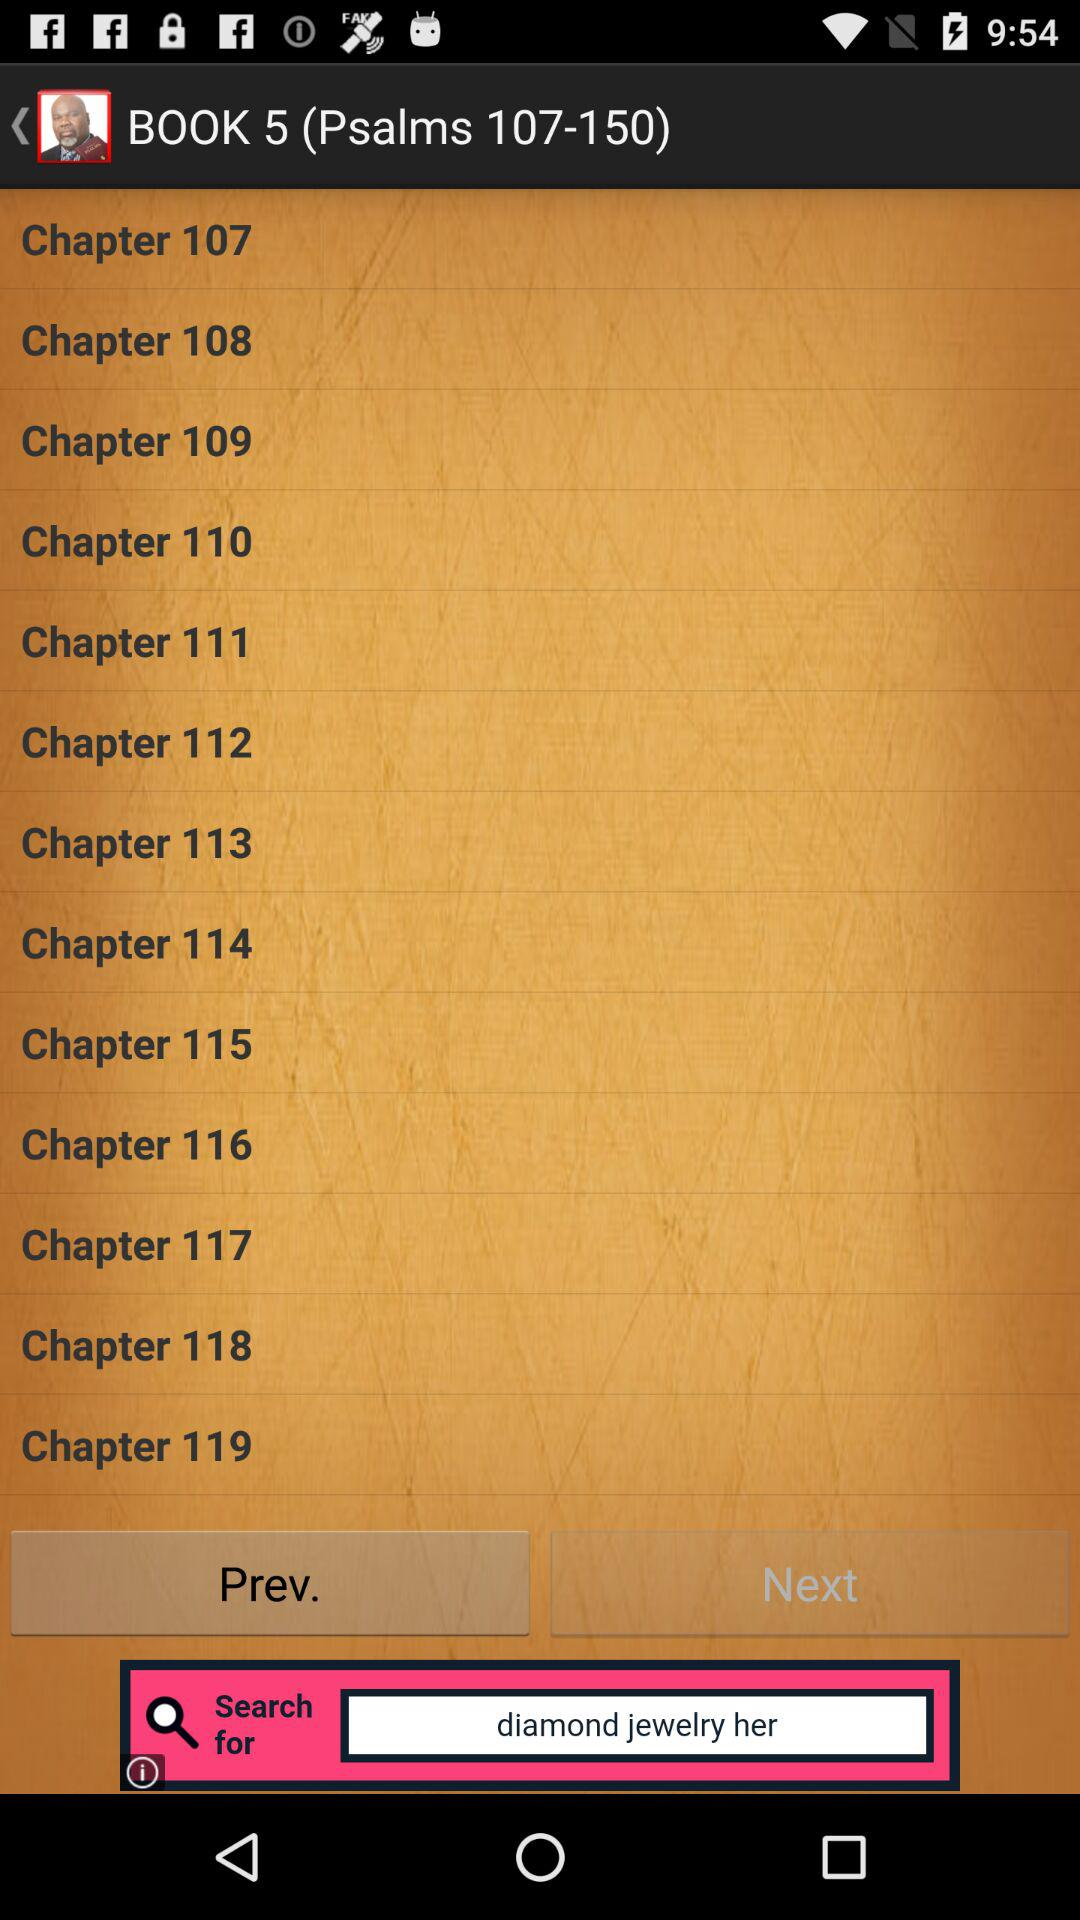How many chapters are there in the book of Psalms?
Answer the question using a single word or phrase. 150 